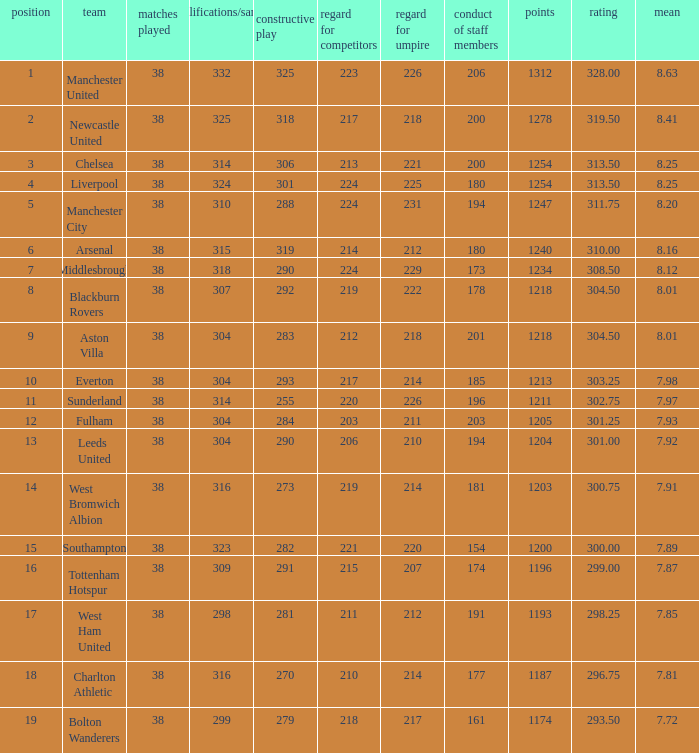Name the most pos for west bromwich albion club 14.0. 